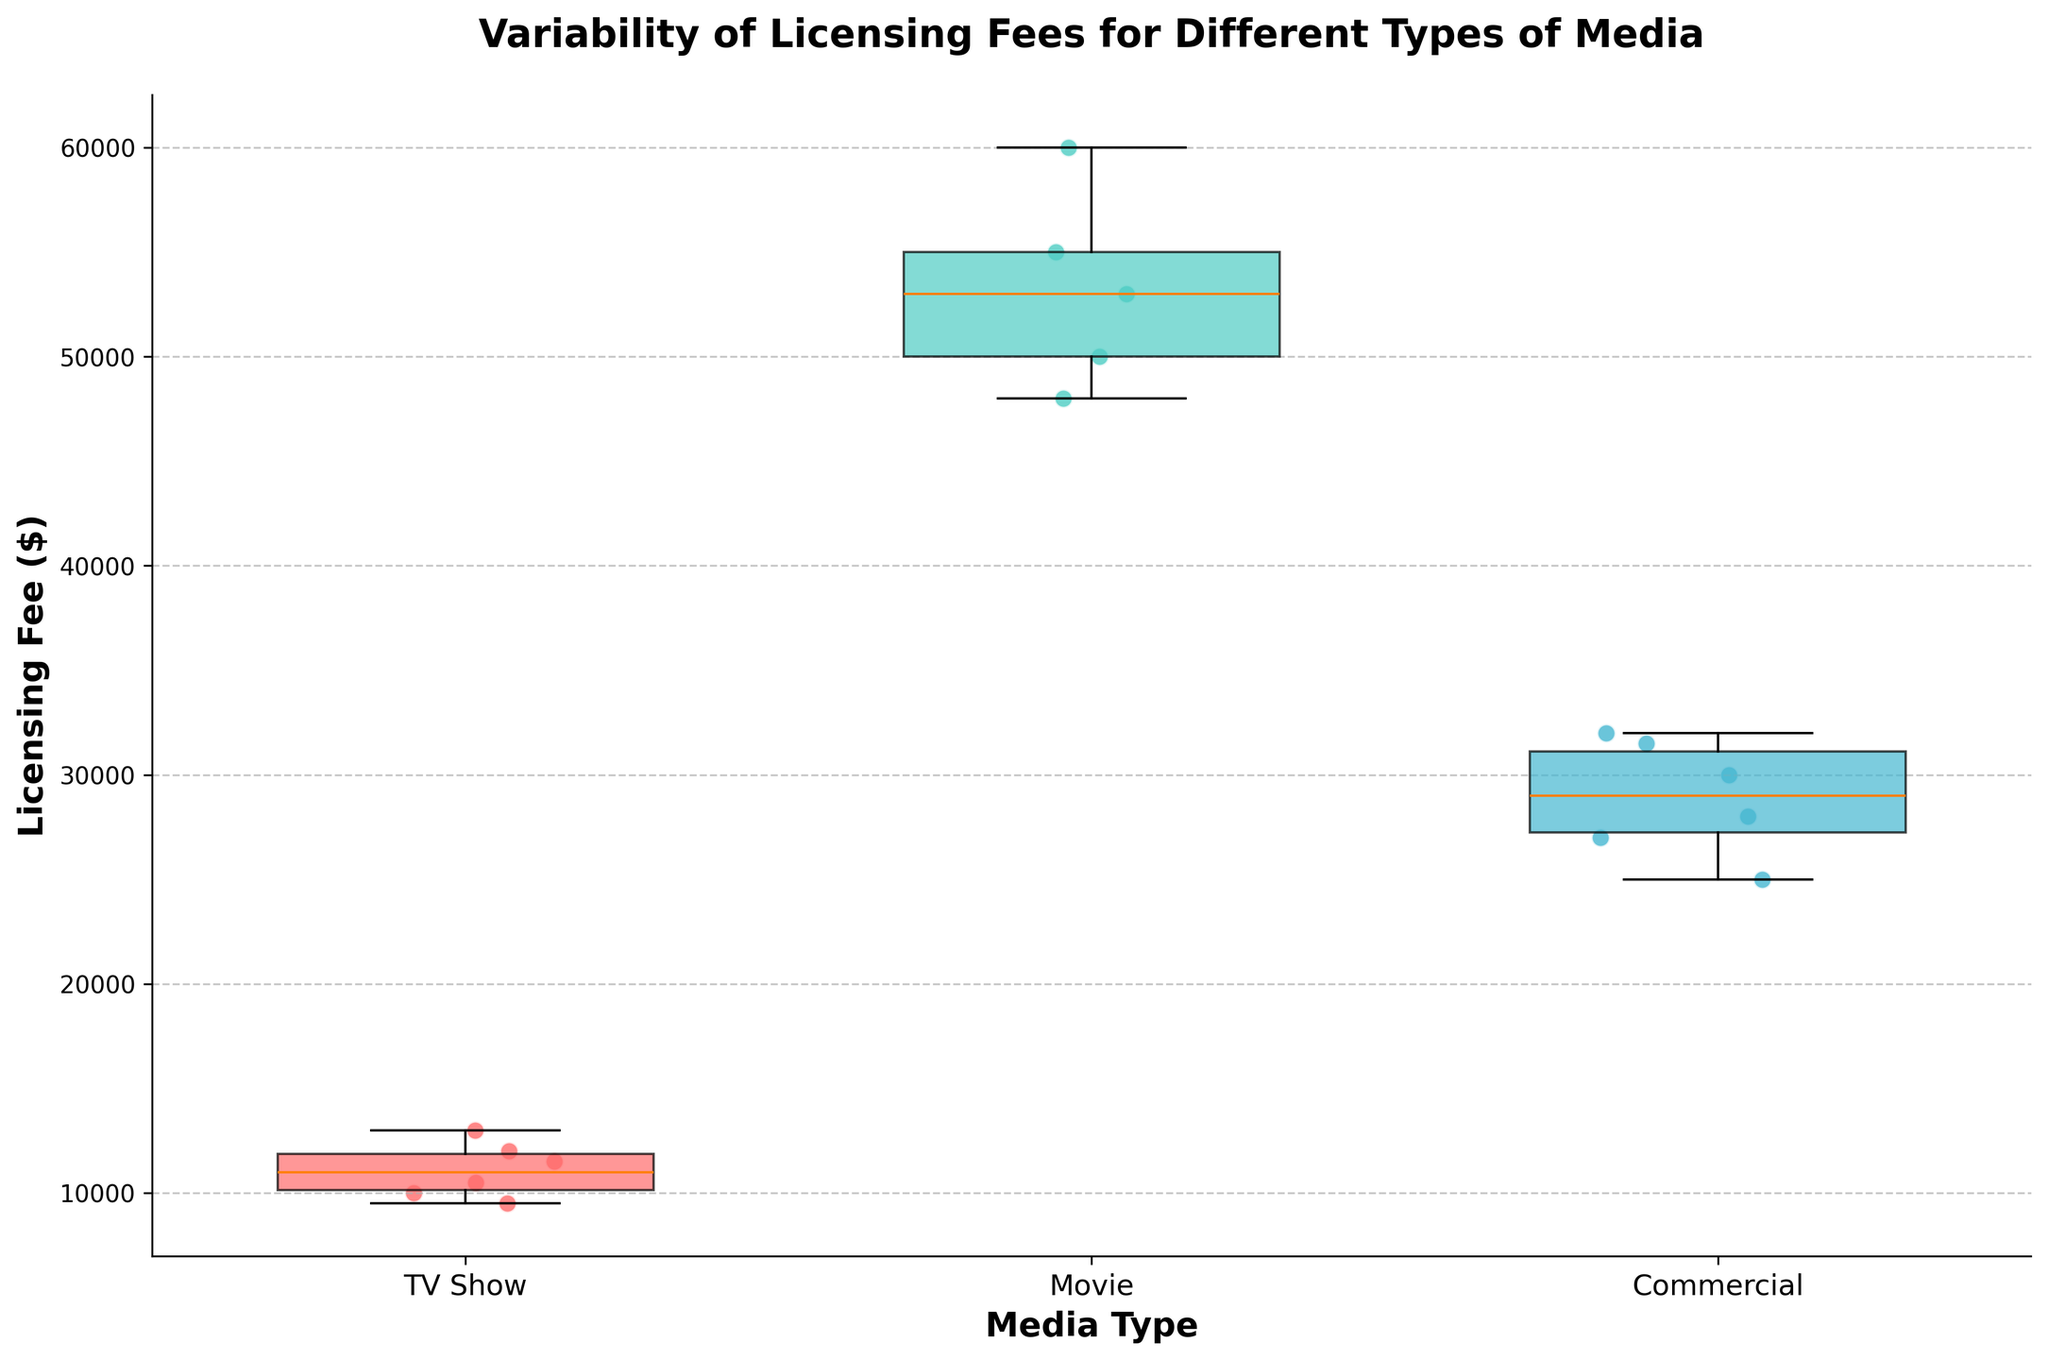What is the title of the plot? The plot's title is located at the top center of the figure, typically in a larger and bolder font. It provides a summary or the main topic of the figure.
Answer: Variability of Licensing Fees for Different Types of Media Which media type has the widest range of licensing fees? To determine the widest range, you need to compare the vertical spans of the boxes and whiskers for each media type. The one with the largest vertical span has the widest range.
Answer: Movie What is the median licensing fee for TV Shows? The median is represented by the line inside the box. For TV Shows, find the horizontal line within the box to determine this value.
Answer: $11250 How do the licensing fees for TV shows compare to commercials in terms of median value? Compare the horizontal line inside the boxes for TV shows and commercials. The median line for TV shows should be compared to the median line for commercials to see which one is higher or lower.
Answer: TV Show What do the scatter points represent in this box plot? The scatter points are specific data points of licensing fees for each entity within the media type. They provide a visual indication of individual values and help show the distribution.
Answer: Individual licensing fees for entities Which media type has the smallest interquartile range (IQR)? The IQR is represented by the height of the box. Compare the heights of the boxes for each media type; the shortest box indicates the smallest IQR.
Answer: Commercial How many unique media types are included in the plot? The number of unique media types can be determined by counting the different labels along the x-axis.
Answer: 3 Are there any outliers indicated in the plot, and if so, which media type has them? Outliers in box plots are typically represented by points that fall outside the whiskers. Identify any such points and note which media type they belong to.
Answer: No outliers are indicated What is the highest licensing fee for movies? The highest value in the movie category can be determined by looking at the top of the whisker or the highest scatter point.
Answer: $60000 What is the range of licensing fees for TV Shows? The range is calculated by subtracting the lowest value from the highest value within the TV Shows category. Identify the highest and lowest points from the whiskers or scatter points and subtract.
Answer: $13000 - $9500 = $3500 